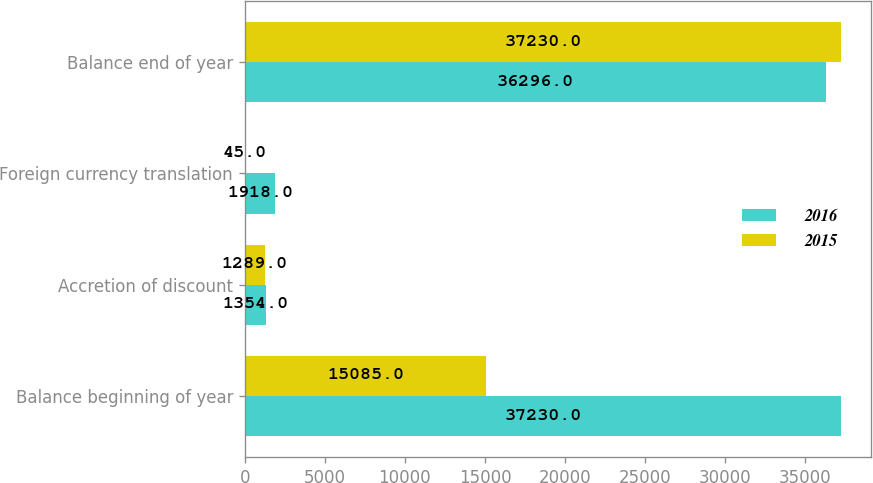<chart> <loc_0><loc_0><loc_500><loc_500><stacked_bar_chart><ecel><fcel>Balance beginning of year<fcel>Accretion of discount<fcel>Foreign currency translation<fcel>Balance end of year<nl><fcel>2016<fcel>37230<fcel>1354<fcel>1918<fcel>36296<nl><fcel>2015<fcel>15085<fcel>1289<fcel>45<fcel>37230<nl></chart> 